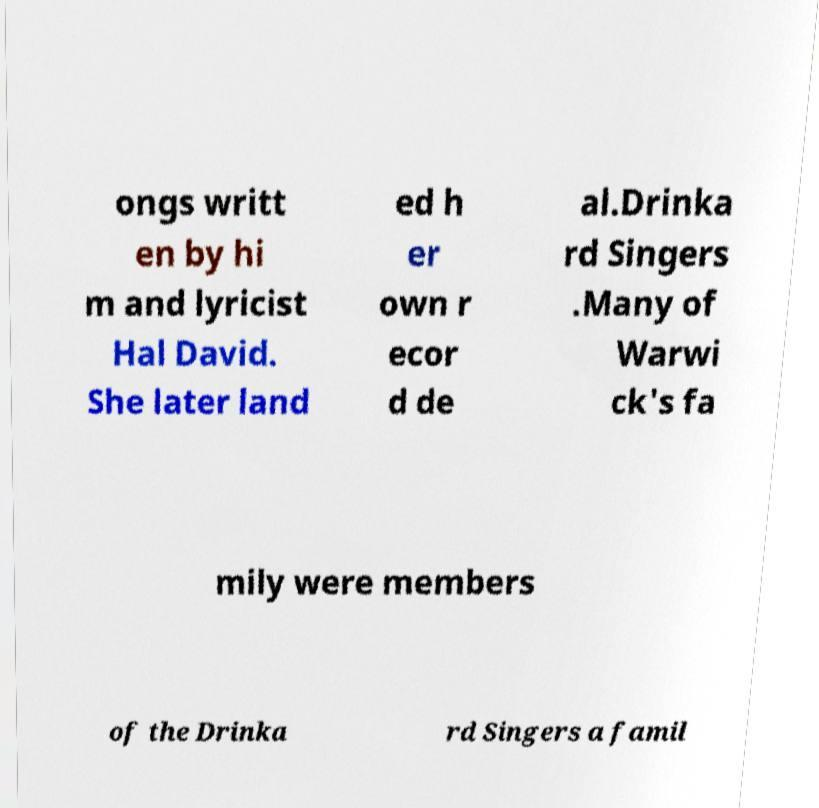Please read and relay the text visible in this image. What does it say? ongs writt en by hi m and lyricist Hal David. She later land ed h er own r ecor d de al.Drinka rd Singers .Many of Warwi ck's fa mily were members of the Drinka rd Singers a famil 